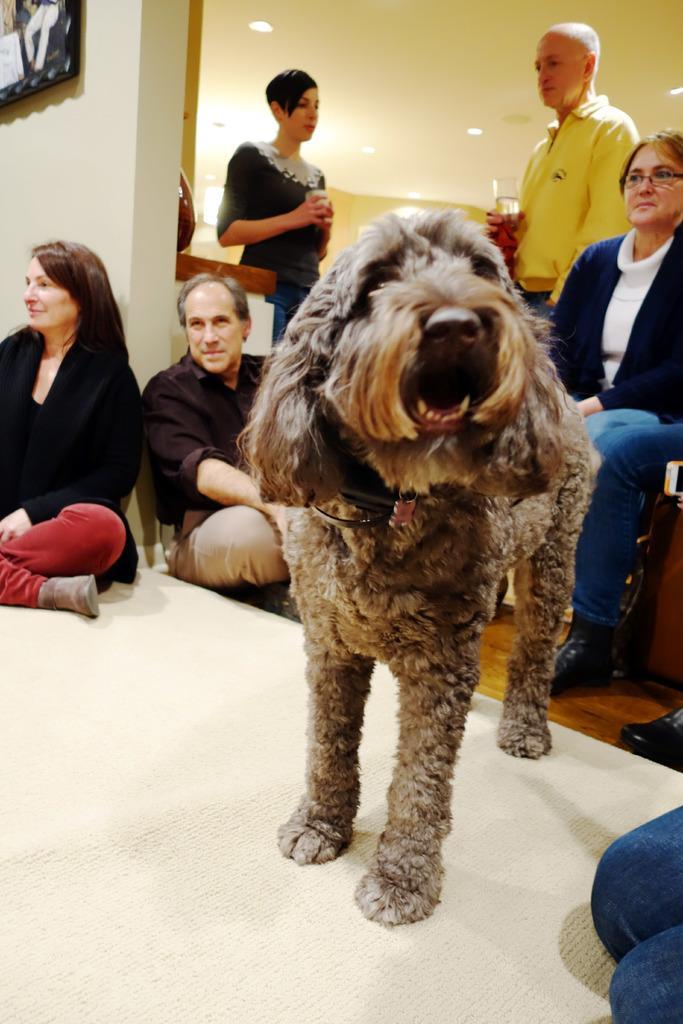How would you summarize this image in a sentence or two? In this image we can see a dog standing on the carpet, persons sitting on the floor and chairs and standing on the floor by holding glass tumblers in their hands. 